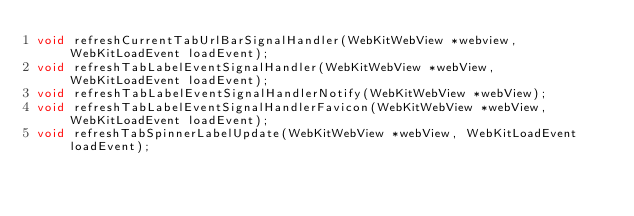<code> <loc_0><loc_0><loc_500><loc_500><_C_>void refreshCurrentTabUrlBarSignalHandler(WebKitWebView *webview, WebKitLoadEvent loadEvent);
void refreshTabLabelEventSignalHandler(WebKitWebView *webView, WebKitLoadEvent loadEvent);
void refreshTabLabelEventSignalHandlerNotify(WebKitWebView *webView);
void refreshTabLabelEventSignalHandlerFavicon(WebKitWebView *webView, WebKitLoadEvent loadEvent);
void refreshTabSpinnerLabelUpdate(WebKitWebView *webView, WebKitLoadEvent loadEvent);</code> 